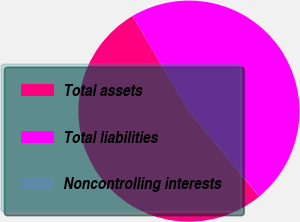Convert chart. <chart><loc_0><loc_0><loc_500><loc_500><pie_chart><fcel>Total assets<fcel>Total liabilities<fcel>Noncontrolling interests<nl><fcel>52.43%<fcel>47.55%<fcel>0.02%<nl></chart> 